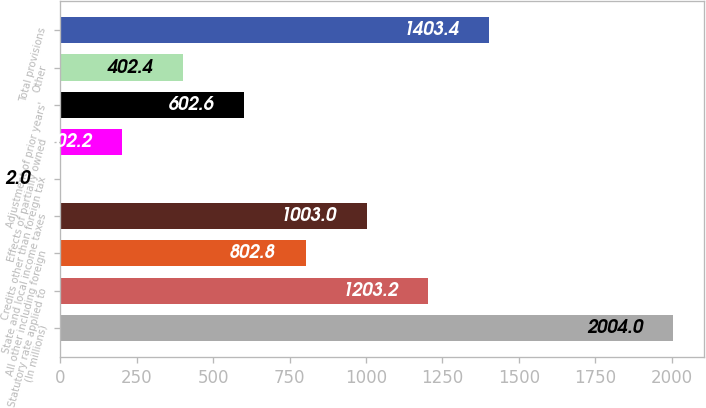<chart> <loc_0><loc_0><loc_500><loc_500><bar_chart><fcel>(In millions)<fcel>Statutory rate applied to<fcel>All other including foreign<fcel>State and local income taxes<fcel>Credits other than foreign tax<fcel>Effects of partially owned<fcel>Adjustment of prior years'<fcel>Other<fcel>Total provisions<nl><fcel>2004<fcel>1203.2<fcel>802.8<fcel>1003<fcel>2<fcel>202.2<fcel>602.6<fcel>402.4<fcel>1403.4<nl></chart> 